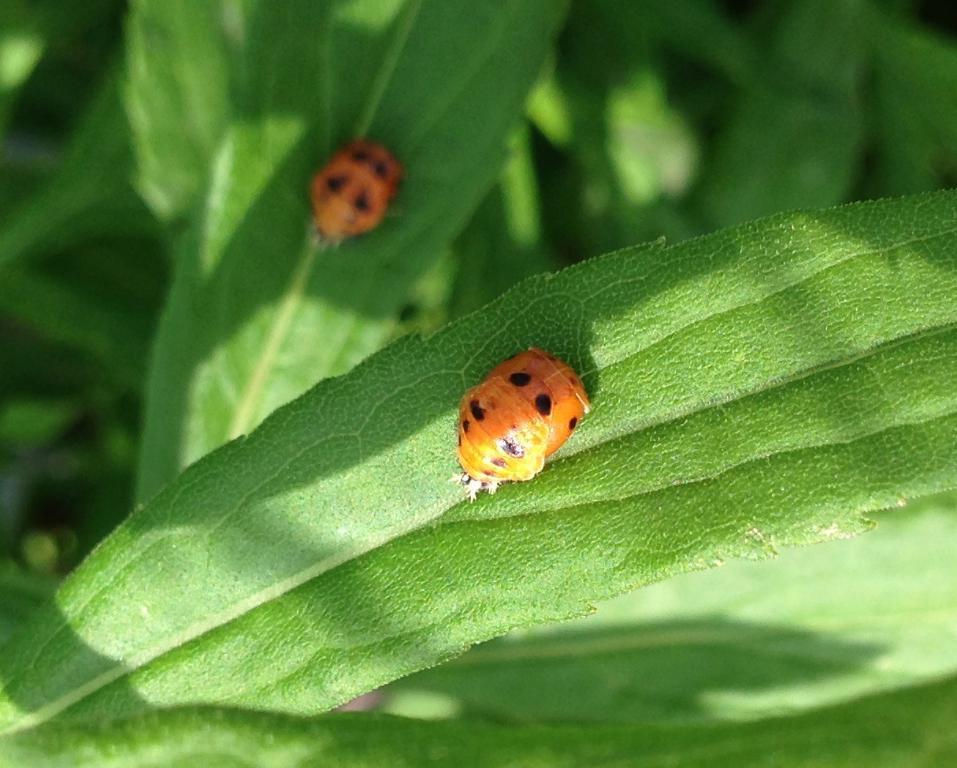What type of creatures can be seen in the image? There are insects in the image. Where are the insects located on the image? The insects are on the leaves. What type of quiver can be seen in the image? There is no quiver present in the image. What type of society do the insects belong to in the image? The image does not provide information about the insects' society. 